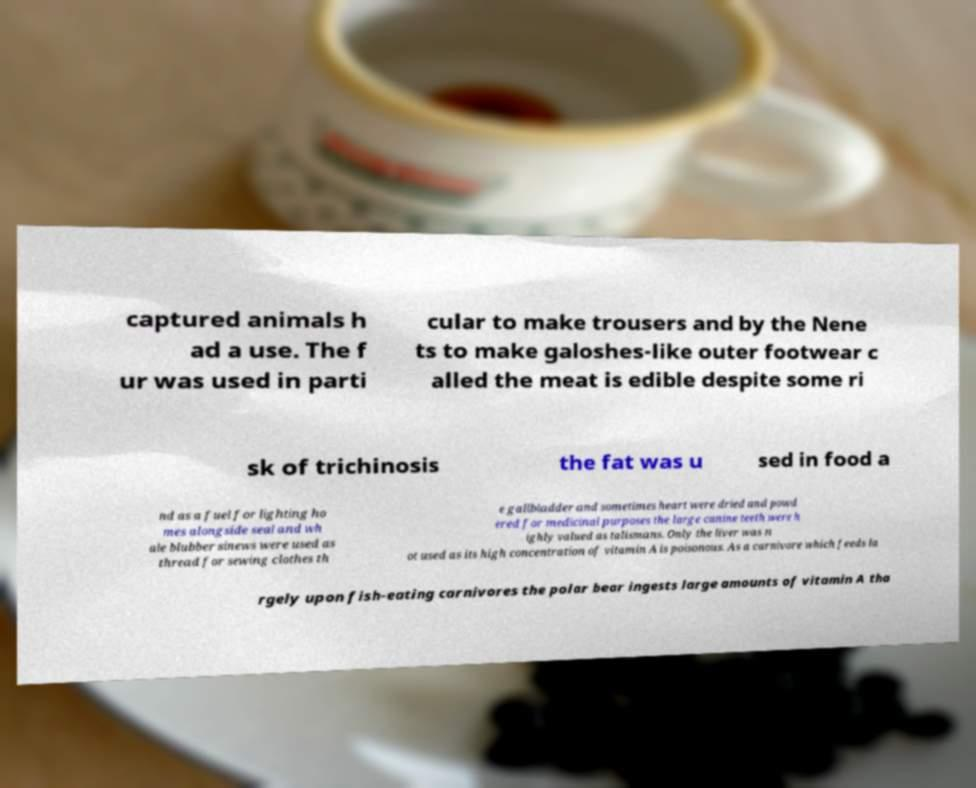Can you accurately transcribe the text from the provided image for me? captured animals h ad a use. The f ur was used in parti cular to make trousers and by the Nene ts to make galoshes-like outer footwear c alled the meat is edible despite some ri sk of trichinosis the fat was u sed in food a nd as a fuel for lighting ho mes alongside seal and wh ale blubber sinews were used as thread for sewing clothes th e gallbladder and sometimes heart were dried and powd ered for medicinal purposes the large canine teeth were h ighly valued as talismans. Only the liver was n ot used as its high concentration of vitamin A is poisonous. As a carnivore which feeds la rgely upon fish-eating carnivores the polar bear ingests large amounts of vitamin A tha 